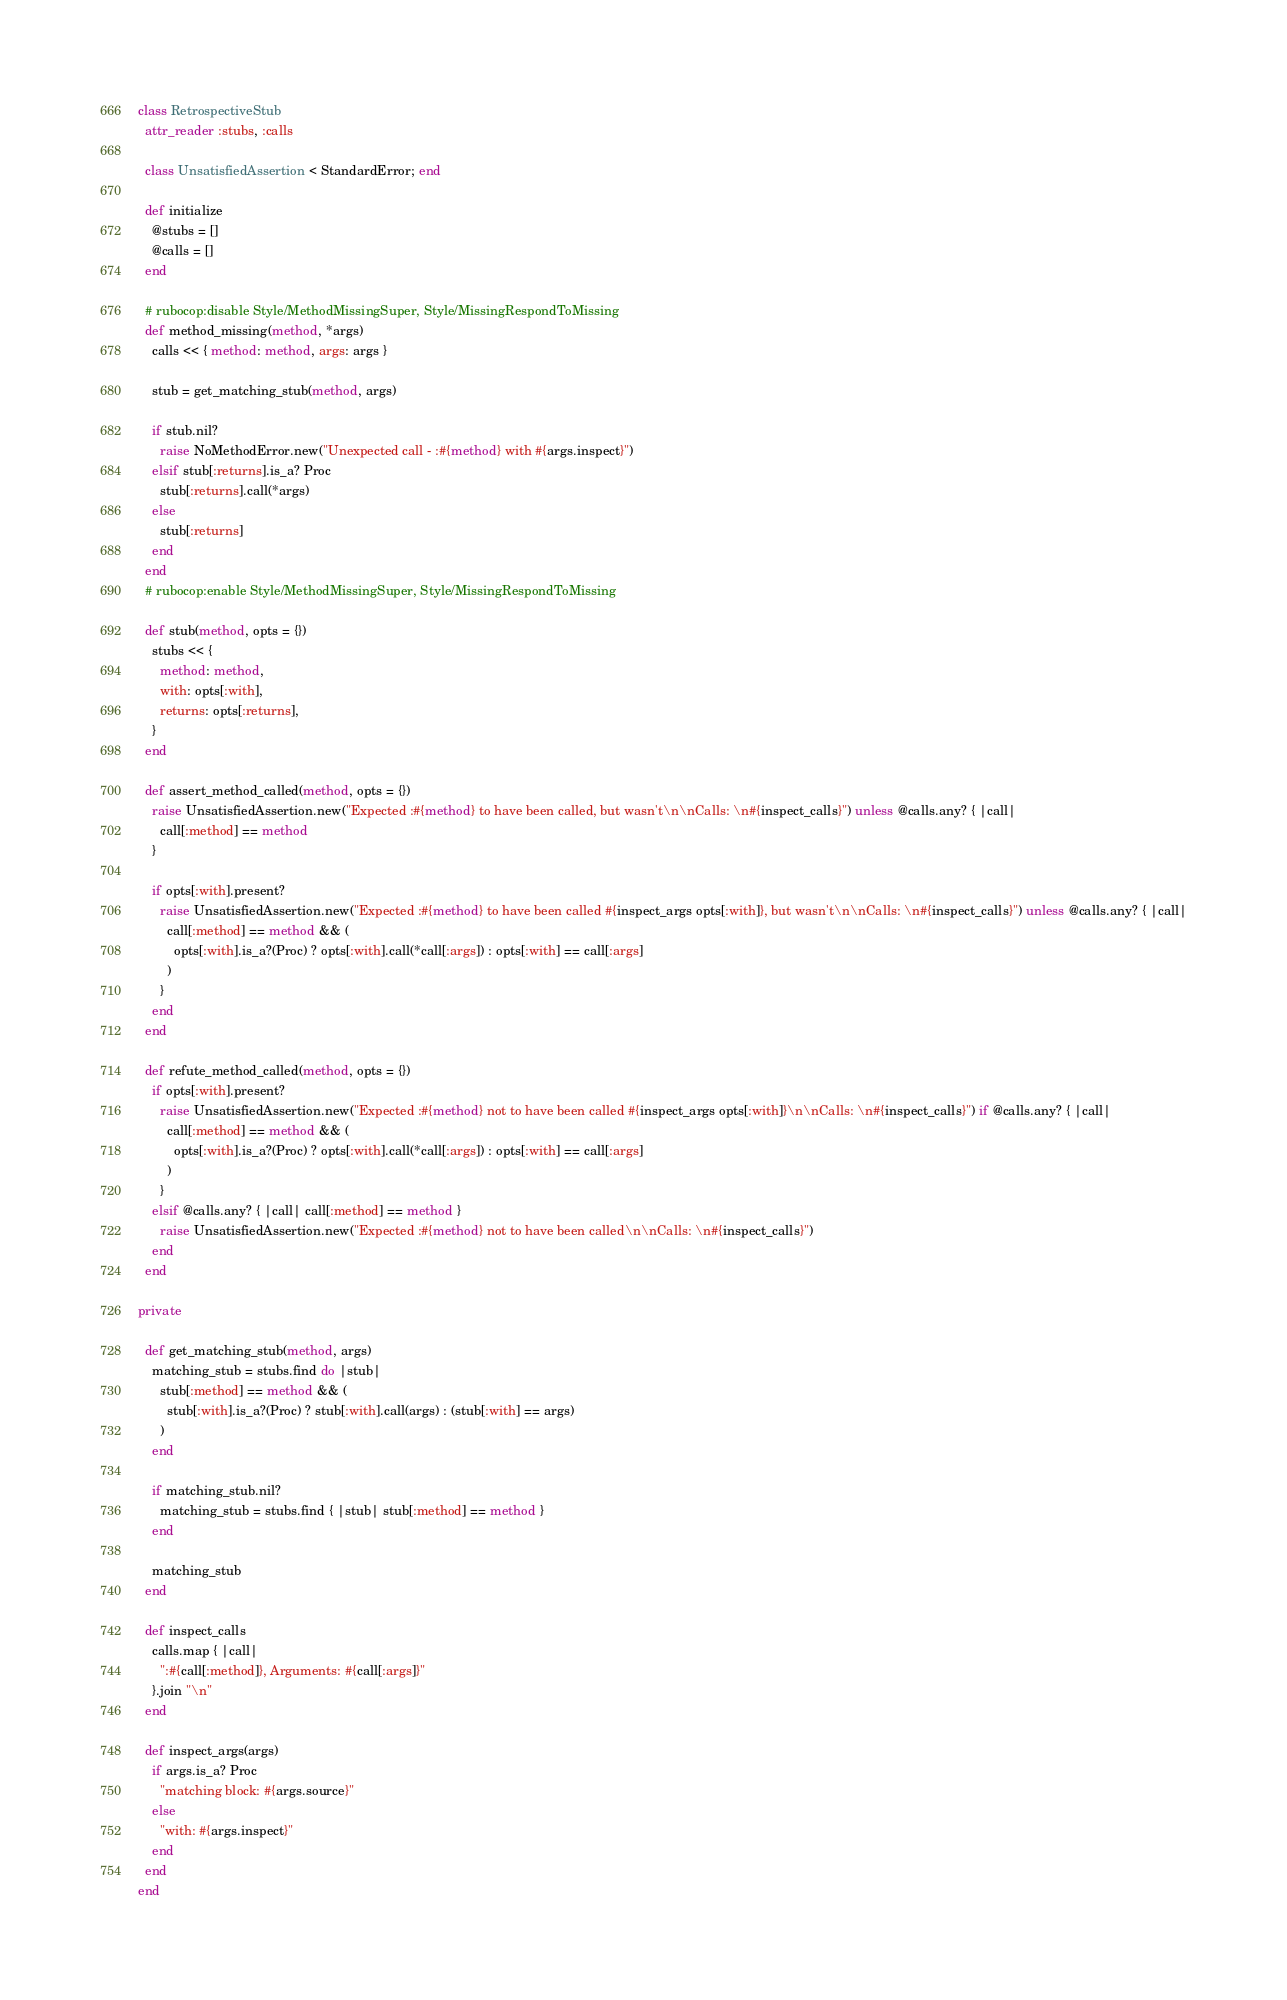<code> <loc_0><loc_0><loc_500><loc_500><_Ruby_>class RetrospectiveStub
  attr_reader :stubs, :calls

  class UnsatisfiedAssertion < StandardError; end

  def initialize
    @stubs = []
    @calls = []
  end

  # rubocop:disable Style/MethodMissingSuper, Style/MissingRespondToMissing
  def method_missing(method, *args)
    calls << { method: method, args: args }

    stub = get_matching_stub(method, args)

    if stub.nil?
      raise NoMethodError.new("Unexpected call - :#{method} with #{args.inspect}")
    elsif stub[:returns].is_a? Proc
      stub[:returns].call(*args)
    else
      stub[:returns]
    end
  end
  # rubocop:enable Style/MethodMissingSuper, Style/MissingRespondToMissing

  def stub(method, opts = {})
    stubs << {
      method: method,
      with: opts[:with],
      returns: opts[:returns],
    }
  end

  def assert_method_called(method, opts = {})
    raise UnsatisfiedAssertion.new("Expected :#{method} to have been called, but wasn't\n\nCalls: \n#{inspect_calls}") unless @calls.any? { |call|
      call[:method] == method
    }

    if opts[:with].present?
      raise UnsatisfiedAssertion.new("Expected :#{method} to have been called #{inspect_args opts[:with]}, but wasn't\n\nCalls: \n#{inspect_calls}") unless @calls.any? { |call|
        call[:method] == method && (
          opts[:with].is_a?(Proc) ? opts[:with].call(*call[:args]) : opts[:with] == call[:args]
        )
      }
    end
  end

  def refute_method_called(method, opts = {})
    if opts[:with].present?
      raise UnsatisfiedAssertion.new("Expected :#{method} not to have been called #{inspect_args opts[:with]}\n\nCalls: \n#{inspect_calls}") if @calls.any? { |call|
        call[:method] == method && (
          opts[:with].is_a?(Proc) ? opts[:with].call(*call[:args]) : opts[:with] == call[:args]
        )
      }
    elsif @calls.any? { |call| call[:method] == method }
      raise UnsatisfiedAssertion.new("Expected :#{method} not to have been called\n\nCalls: \n#{inspect_calls}")
    end
  end

private

  def get_matching_stub(method, args)
    matching_stub = stubs.find do |stub|
      stub[:method] == method && (
        stub[:with].is_a?(Proc) ? stub[:with].call(args) : (stub[:with] == args)
      )
    end

    if matching_stub.nil?
      matching_stub = stubs.find { |stub| stub[:method] == method }
    end

    matching_stub
  end

  def inspect_calls
    calls.map { |call|
      ":#{call[:method]}, Arguments: #{call[:args]}"
    }.join "\n"
  end

  def inspect_args(args)
    if args.is_a? Proc
      "matching block: #{args.source}"
    else
      "with: #{args.inspect}"
    end
  end
end
</code> 